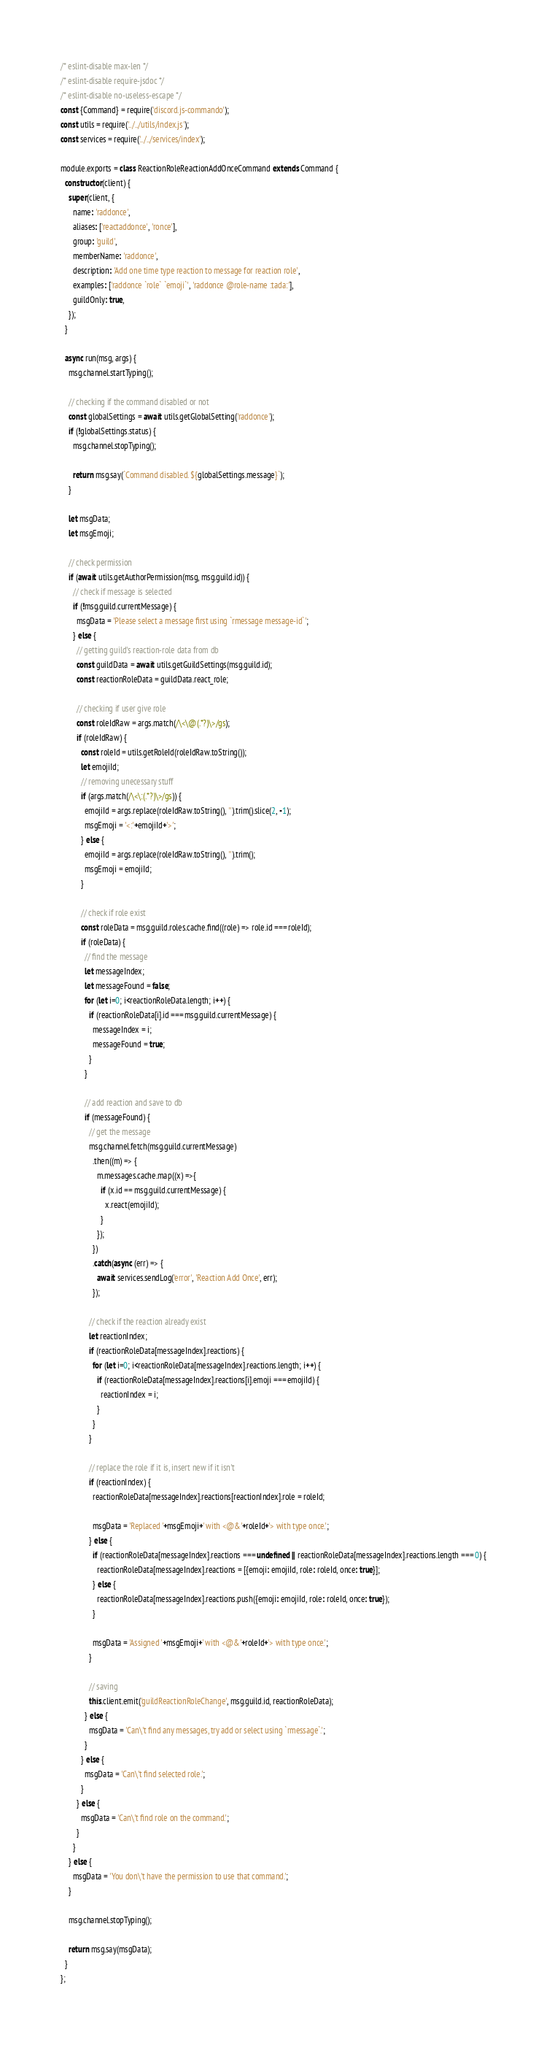Convert code to text. <code><loc_0><loc_0><loc_500><loc_500><_JavaScript_>/* eslint-disable max-len */
/* eslint-disable require-jsdoc */
/* eslint-disable no-useless-escape */
const {Command} = require('discord.js-commando');
const utils = require('../../utils/index.js');
const services = require('../../services/index');

module.exports = class ReactionRoleReactionAddOnceCommand extends Command {
  constructor(client) {
    super(client, {
      name: 'raddonce',
      aliases: ['reactaddonce', 'ronce'],
      group: 'guild',
      memberName: 'raddonce',
      description: 'Add one time type reaction to message for reaction role',
      examples: ['raddonce `role` `emoji`', 'raddonce @role-name :tada:'],
      guildOnly: true,
    });
  }

  async run(msg, args) {
    msg.channel.startTyping();

    // checking if the command disabled or not
    const globalSettings = await utils.getGlobalSetting('raddonce');
    if (!globalSettings.status) {
      msg.channel.stopTyping();

      return msg.say(`Command disabled. ${globalSettings.message}`);
    }

    let msgData;
    let msgEmoji;

    // check permission
    if (await utils.getAuthorPermission(msg, msg.guild.id)) {
      // check if message is selected
      if (!msg.guild.currentMessage) {
        msgData = 'Please select a message first using `rmessage message-id`';
      } else {
        // getting guild's reaction-role data from db
        const guildData = await utils.getGuildSettings(msg.guild.id);
        const reactionRoleData = guildData.react_role;

        // checking if user give role
        const roleIdRaw = args.match(/\<\@(.*?)\>/gs);
        if (roleIdRaw) {
          const roleId = utils.getRoleId(roleIdRaw.toString());
          let emojiId;
          // removing unecessary stuff
          if (args.match(/\<\:(.*?)\>/gs)) {
            emojiId = args.replace(roleIdRaw.toString(), '').trim().slice(2, -1);
            msgEmoji = '<:'+emojiId+'>';
          } else {
            emojiId = args.replace(roleIdRaw.toString(), '').trim();
            msgEmoji = emojiId;
          }

          // check if role exist
          const roleData = msg.guild.roles.cache.find((role) => role.id === roleId);
          if (roleData) {
            // find the message
            let messageIndex;
            let messageFound = false;
            for (let i=0; i<reactionRoleData.length; i++) {
              if (reactionRoleData[i].id === msg.guild.currentMessage) {
                messageIndex = i;
                messageFound = true;
              }
            }

            // add reaction and save to db
            if (messageFound) {
              // get the message
              msg.channel.fetch(msg.guild.currentMessage)
                .then((m) => {
                  m.messages.cache.map((x) =>{
                    if (x.id == msg.guild.currentMessage) {
                      x.react(emojiId);
                    }
                  });
                })
                .catch(async (err) => {
                  await services.sendLog('error', 'Reaction Add Once', err);
                });

              // check if the reaction already exist
              let reactionIndex;
              if (reactionRoleData[messageIndex].reactions) {
                for (let i=0; i<reactionRoleData[messageIndex].reactions.length; i++) {
                  if (reactionRoleData[messageIndex].reactions[i].emoji === emojiId) {
                    reactionIndex = i;
                  }
                }
              }

              // replace the role if it is, insert new if it isn't
              if (reactionIndex) {
                reactionRoleData[messageIndex].reactions[reactionIndex].role = roleId;

                msgData = 'Replaced '+msgEmoji+' with <@&'+roleId+'> with type once.';
              } else {
                if (reactionRoleData[messageIndex].reactions === undefined || reactionRoleData[messageIndex].reactions.length === 0) {
                  reactionRoleData[messageIndex].reactions = [{emoji: emojiId, role: roleId, once: true}];
                } else {
                  reactionRoleData[messageIndex].reactions.push({emoji: emojiId, role: roleId, once: true});
                }

                msgData = 'Assigned '+msgEmoji+' with <@&'+roleId+'> with type once.';
              }

              // saving
              this.client.emit('guildReactionRoleChange', msg.guild.id, reactionRoleData);
            } else {
              msgData = 'Can\'t find any messages, try add or select using `rmessage`.';
            }
          } else {
            msgData = 'Can\'t find selected role.';
          }
        } else {
          msgData = 'Can\'t find role on the command.';
        }
      }
    } else {
      msgData = 'You don\'t have the permission to use that command.';
    }

    msg.channel.stopTyping();

    return msg.say(msgData);
  }
};
</code> 